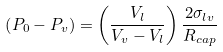Convert formula to latex. <formula><loc_0><loc_0><loc_500><loc_500>\left ( P _ { 0 } - P _ { v } \right ) = \left ( \frac { V _ { l } } { V _ { v } - V _ { l } } \right ) \frac { 2 \sigma _ { l v } } { R _ { c a p } }</formula> 